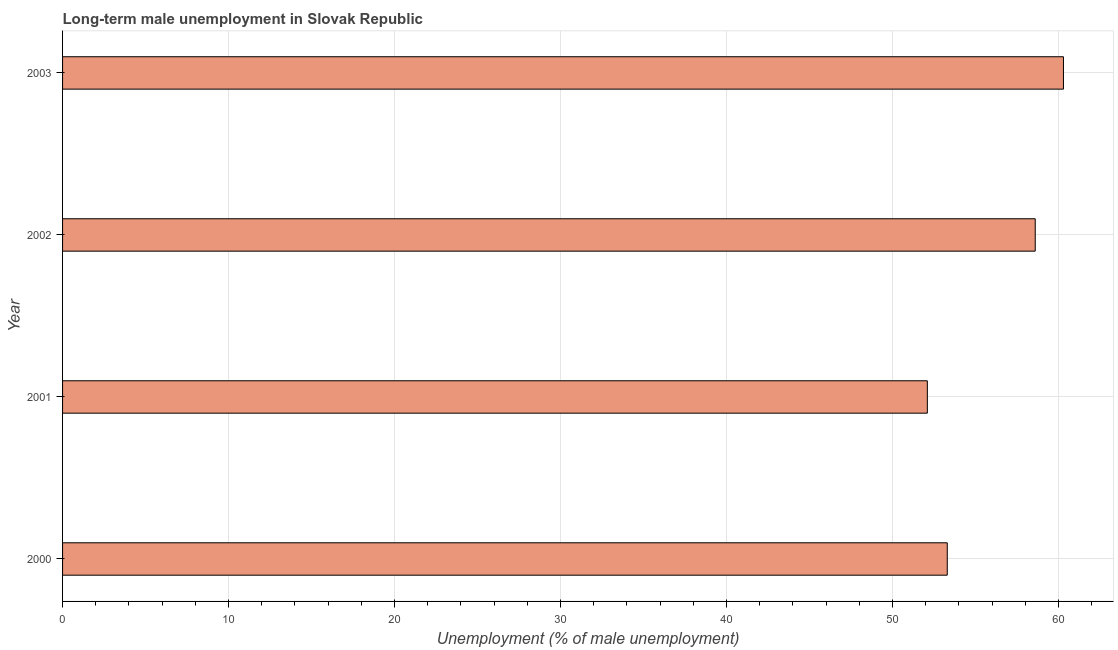Does the graph contain grids?
Provide a short and direct response. Yes. What is the title of the graph?
Your response must be concise. Long-term male unemployment in Slovak Republic. What is the label or title of the X-axis?
Ensure brevity in your answer.  Unemployment (% of male unemployment). What is the label or title of the Y-axis?
Your answer should be compact. Year. What is the long-term male unemployment in 2003?
Your response must be concise. 60.3. Across all years, what is the maximum long-term male unemployment?
Offer a very short reply. 60.3. Across all years, what is the minimum long-term male unemployment?
Offer a terse response. 52.1. In which year was the long-term male unemployment maximum?
Keep it short and to the point. 2003. What is the sum of the long-term male unemployment?
Give a very brief answer. 224.3. What is the average long-term male unemployment per year?
Provide a succinct answer. 56.08. What is the median long-term male unemployment?
Offer a very short reply. 55.95. In how many years, is the long-term male unemployment greater than 28 %?
Provide a succinct answer. 4. What is the ratio of the long-term male unemployment in 2000 to that in 2002?
Offer a terse response. 0.91. Is the difference between the long-term male unemployment in 2002 and 2003 greater than the difference between any two years?
Keep it short and to the point. No. What is the difference between the highest and the second highest long-term male unemployment?
Make the answer very short. 1.7. How many bars are there?
Provide a short and direct response. 4. Are all the bars in the graph horizontal?
Provide a short and direct response. Yes. How many years are there in the graph?
Keep it short and to the point. 4. What is the difference between two consecutive major ticks on the X-axis?
Your response must be concise. 10. What is the Unemployment (% of male unemployment) of 2000?
Make the answer very short. 53.3. What is the Unemployment (% of male unemployment) in 2001?
Provide a short and direct response. 52.1. What is the Unemployment (% of male unemployment) of 2002?
Your response must be concise. 58.6. What is the Unemployment (% of male unemployment) of 2003?
Give a very brief answer. 60.3. What is the difference between the Unemployment (% of male unemployment) in 2000 and 2001?
Make the answer very short. 1.2. What is the difference between the Unemployment (% of male unemployment) in 2000 and 2002?
Give a very brief answer. -5.3. What is the difference between the Unemployment (% of male unemployment) in 2000 and 2003?
Offer a terse response. -7. What is the ratio of the Unemployment (% of male unemployment) in 2000 to that in 2001?
Your answer should be very brief. 1.02. What is the ratio of the Unemployment (% of male unemployment) in 2000 to that in 2002?
Provide a succinct answer. 0.91. What is the ratio of the Unemployment (% of male unemployment) in 2000 to that in 2003?
Give a very brief answer. 0.88. What is the ratio of the Unemployment (% of male unemployment) in 2001 to that in 2002?
Your answer should be compact. 0.89. What is the ratio of the Unemployment (% of male unemployment) in 2001 to that in 2003?
Provide a succinct answer. 0.86. 